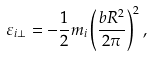<formula> <loc_0><loc_0><loc_500><loc_500>\varepsilon _ { i \perp } = - \frac { 1 } { 2 } m _ { i } \left ( \frac { b R ^ { 2 } } { 2 \pi } \right ) ^ { 2 } ,</formula> 